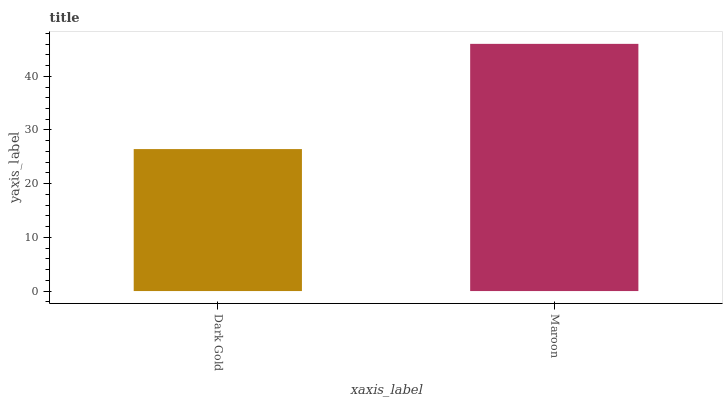Is Dark Gold the minimum?
Answer yes or no. Yes. Is Maroon the maximum?
Answer yes or no. Yes. Is Maroon the minimum?
Answer yes or no. No. Is Maroon greater than Dark Gold?
Answer yes or no. Yes. Is Dark Gold less than Maroon?
Answer yes or no. Yes. Is Dark Gold greater than Maroon?
Answer yes or no. No. Is Maroon less than Dark Gold?
Answer yes or no. No. Is Maroon the high median?
Answer yes or no. Yes. Is Dark Gold the low median?
Answer yes or no. Yes. Is Dark Gold the high median?
Answer yes or no. No. Is Maroon the low median?
Answer yes or no. No. 